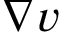Convert formula to latex. <formula><loc_0><loc_0><loc_500><loc_500>\nabla v</formula> 